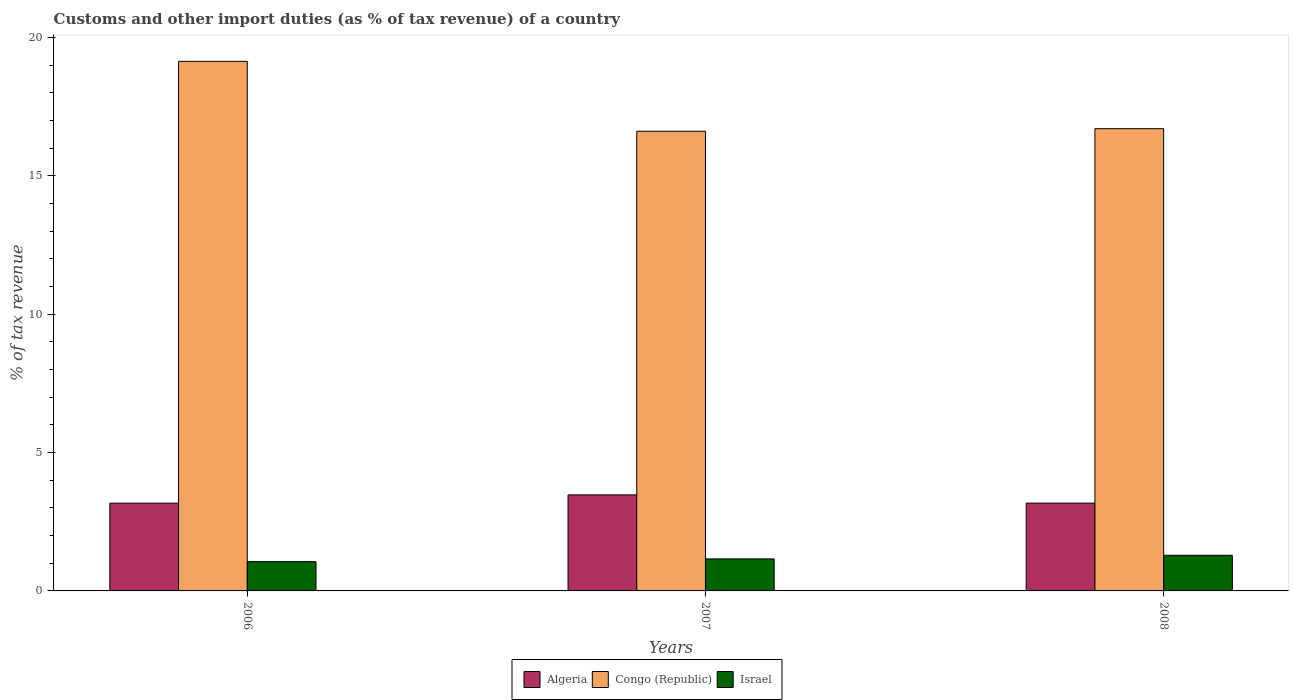How many groups of bars are there?
Your response must be concise. 3. Are the number of bars per tick equal to the number of legend labels?
Provide a short and direct response. Yes. How many bars are there on the 1st tick from the left?
Ensure brevity in your answer.  3. How many bars are there on the 1st tick from the right?
Give a very brief answer. 3. What is the label of the 3rd group of bars from the left?
Your answer should be compact. 2008. What is the percentage of tax revenue from customs in Algeria in 2006?
Your answer should be compact. 3.17. Across all years, what is the maximum percentage of tax revenue from customs in Algeria?
Ensure brevity in your answer.  3.47. Across all years, what is the minimum percentage of tax revenue from customs in Algeria?
Make the answer very short. 3.17. In which year was the percentage of tax revenue from customs in Israel maximum?
Keep it short and to the point. 2008. What is the total percentage of tax revenue from customs in Congo (Republic) in the graph?
Provide a succinct answer. 52.45. What is the difference between the percentage of tax revenue from customs in Congo (Republic) in 2006 and that in 2008?
Keep it short and to the point. 2.43. What is the difference between the percentage of tax revenue from customs in Congo (Republic) in 2008 and the percentage of tax revenue from customs in Israel in 2006?
Offer a very short reply. 15.65. What is the average percentage of tax revenue from customs in Congo (Republic) per year?
Offer a very short reply. 17.48. In the year 2006, what is the difference between the percentage of tax revenue from customs in Congo (Republic) and percentage of tax revenue from customs in Algeria?
Your answer should be very brief. 15.97. In how many years, is the percentage of tax revenue from customs in Israel greater than 15 %?
Your answer should be compact. 0. What is the ratio of the percentage of tax revenue from customs in Congo (Republic) in 2006 to that in 2008?
Your response must be concise. 1.15. Is the percentage of tax revenue from customs in Congo (Republic) in 2007 less than that in 2008?
Your answer should be very brief. Yes. What is the difference between the highest and the second highest percentage of tax revenue from customs in Israel?
Provide a succinct answer. 0.13. What is the difference between the highest and the lowest percentage of tax revenue from customs in Israel?
Keep it short and to the point. 0.23. Is the sum of the percentage of tax revenue from customs in Israel in 2007 and 2008 greater than the maximum percentage of tax revenue from customs in Algeria across all years?
Keep it short and to the point. No. What does the 2nd bar from the left in 2006 represents?
Your answer should be compact. Congo (Republic). What does the 1st bar from the right in 2007 represents?
Your answer should be very brief. Israel. Is it the case that in every year, the sum of the percentage of tax revenue from customs in Congo (Republic) and percentage of tax revenue from customs in Israel is greater than the percentage of tax revenue from customs in Algeria?
Keep it short and to the point. Yes. How many bars are there?
Give a very brief answer. 9. Are all the bars in the graph horizontal?
Offer a very short reply. No. What is the difference between two consecutive major ticks on the Y-axis?
Ensure brevity in your answer.  5. Are the values on the major ticks of Y-axis written in scientific E-notation?
Keep it short and to the point. No. Does the graph contain any zero values?
Give a very brief answer. No. Does the graph contain grids?
Your answer should be compact. No. How many legend labels are there?
Give a very brief answer. 3. How are the legend labels stacked?
Make the answer very short. Horizontal. What is the title of the graph?
Make the answer very short. Customs and other import duties (as % of tax revenue) of a country. Does "Vietnam" appear as one of the legend labels in the graph?
Make the answer very short. No. What is the label or title of the X-axis?
Keep it short and to the point. Years. What is the label or title of the Y-axis?
Provide a short and direct response. % of tax revenue. What is the % of tax revenue in Algeria in 2006?
Your response must be concise. 3.17. What is the % of tax revenue in Congo (Republic) in 2006?
Your answer should be very brief. 19.14. What is the % of tax revenue in Israel in 2006?
Your answer should be very brief. 1.06. What is the % of tax revenue in Algeria in 2007?
Make the answer very short. 3.47. What is the % of tax revenue in Congo (Republic) in 2007?
Provide a succinct answer. 16.61. What is the % of tax revenue in Israel in 2007?
Your answer should be compact. 1.16. What is the % of tax revenue of Algeria in 2008?
Provide a short and direct response. 3.17. What is the % of tax revenue of Congo (Republic) in 2008?
Provide a succinct answer. 16.7. What is the % of tax revenue in Israel in 2008?
Make the answer very short. 1.29. Across all years, what is the maximum % of tax revenue of Algeria?
Your answer should be compact. 3.47. Across all years, what is the maximum % of tax revenue in Congo (Republic)?
Give a very brief answer. 19.14. Across all years, what is the maximum % of tax revenue of Israel?
Offer a very short reply. 1.29. Across all years, what is the minimum % of tax revenue in Algeria?
Give a very brief answer. 3.17. Across all years, what is the minimum % of tax revenue in Congo (Republic)?
Offer a very short reply. 16.61. Across all years, what is the minimum % of tax revenue of Israel?
Provide a succinct answer. 1.06. What is the total % of tax revenue of Algeria in the graph?
Provide a short and direct response. 9.81. What is the total % of tax revenue in Congo (Republic) in the graph?
Give a very brief answer. 52.45. What is the total % of tax revenue of Israel in the graph?
Make the answer very short. 3.5. What is the difference between the % of tax revenue of Algeria in 2006 and that in 2007?
Make the answer very short. -0.3. What is the difference between the % of tax revenue in Congo (Republic) in 2006 and that in 2007?
Your answer should be compact. 2.53. What is the difference between the % of tax revenue in Israel in 2006 and that in 2007?
Make the answer very short. -0.1. What is the difference between the % of tax revenue in Algeria in 2006 and that in 2008?
Your response must be concise. -0. What is the difference between the % of tax revenue of Congo (Republic) in 2006 and that in 2008?
Provide a short and direct response. 2.43. What is the difference between the % of tax revenue of Israel in 2006 and that in 2008?
Your response must be concise. -0.23. What is the difference between the % of tax revenue in Algeria in 2007 and that in 2008?
Your answer should be compact. 0.3. What is the difference between the % of tax revenue of Congo (Republic) in 2007 and that in 2008?
Your answer should be very brief. -0.09. What is the difference between the % of tax revenue in Israel in 2007 and that in 2008?
Your answer should be very brief. -0.13. What is the difference between the % of tax revenue in Algeria in 2006 and the % of tax revenue in Congo (Republic) in 2007?
Keep it short and to the point. -13.44. What is the difference between the % of tax revenue in Algeria in 2006 and the % of tax revenue in Israel in 2007?
Make the answer very short. 2.01. What is the difference between the % of tax revenue in Congo (Republic) in 2006 and the % of tax revenue in Israel in 2007?
Provide a short and direct response. 17.98. What is the difference between the % of tax revenue of Algeria in 2006 and the % of tax revenue of Congo (Republic) in 2008?
Make the answer very short. -13.53. What is the difference between the % of tax revenue in Algeria in 2006 and the % of tax revenue in Israel in 2008?
Your answer should be very brief. 1.88. What is the difference between the % of tax revenue in Congo (Republic) in 2006 and the % of tax revenue in Israel in 2008?
Your answer should be very brief. 17.85. What is the difference between the % of tax revenue in Algeria in 2007 and the % of tax revenue in Congo (Republic) in 2008?
Your answer should be compact. -13.23. What is the difference between the % of tax revenue in Algeria in 2007 and the % of tax revenue in Israel in 2008?
Offer a very short reply. 2.18. What is the difference between the % of tax revenue of Congo (Republic) in 2007 and the % of tax revenue of Israel in 2008?
Offer a terse response. 15.32. What is the average % of tax revenue in Algeria per year?
Provide a short and direct response. 3.27. What is the average % of tax revenue in Congo (Republic) per year?
Keep it short and to the point. 17.48. What is the average % of tax revenue in Israel per year?
Provide a succinct answer. 1.17. In the year 2006, what is the difference between the % of tax revenue in Algeria and % of tax revenue in Congo (Republic)?
Keep it short and to the point. -15.97. In the year 2006, what is the difference between the % of tax revenue of Algeria and % of tax revenue of Israel?
Make the answer very short. 2.11. In the year 2006, what is the difference between the % of tax revenue in Congo (Republic) and % of tax revenue in Israel?
Give a very brief answer. 18.08. In the year 2007, what is the difference between the % of tax revenue of Algeria and % of tax revenue of Congo (Republic)?
Ensure brevity in your answer.  -13.14. In the year 2007, what is the difference between the % of tax revenue in Algeria and % of tax revenue in Israel?
Provide a succinct answer. 2.31. In the year 2007, what is the difference between the % of tax revenue in Congo (Republic) and % of tax revenue in Israel?
Provide a succinct answer. 15.45. In the year 2008, what is the difference between the % of tax revenue in Algeria and % of tax revenue in Congo (Republic)?
Give a very brief answer. -13.53. In the year 2008, what is the difference between the % of tax revenue in Algeria and % of tax revenue in Israel?
Keep it short and to the point. 1.88. In the year 2008, what is the difference between the % of tax revenue in Congo (Republic) and % of tax revenue in Israel?
Your answer should be compact. 15.42. What is the ratio of the % of tax revenue of Algeria in 2006 to that in 2007?
Provide a short and direct response. 0.91. What is the ratio of the % of tax revenue in Congo (Republic) in 2006 to that in 2007?
Give a very brief answer. 1.15. What is the ratio of the % of tax revenue of Israel in 2006 to that in 2007?
Give a very brief answer. 0.91. What is the ratio of the % of tax revenue in Algeria in 2006 to that in 2008?
Make the answer very short. 1. What is the ratio of the % of tax revenue in Congo (Republic) in 2006 to that in 2008?
Offer a very short reply. 1.15. What is the ratio of the % of tax revenue in Israel in 2006 to that in 2008?
Ensure brevity in your answer.  0.82. What is the ratio of the % of tax revenue in Algeria in 2007 to that in 2008?
Give a very brief answer. 1.09. What is the ratio of the % of tax revenue of Israel in 2007 to that in 2008?
Your answer should be compact. 0.9. What is the difference between the highest and the second highest % of tax revenue of Algeria?
Your answer should be very brief. 0.3. What is the difference between the highest and the second highest % of tax revenue of Congo (Republic)?
Make the answer very short. 2.43. What is the difference between the highest and the second highest % of tax revenue in Israel?
Make the answer very short. 0.13. What is the difference between the highest and the lowest % of tax revenue in Algeria?
Offer a terse response. 0.3. What is the difference between the highest and the lowest % of tax revenue of Congo (Republic)?
Ensure brevity in your answer.  2.53. What is the difference between the highest and the lowest % of tax revenue of Israel?
Offer a terse response. 0.23. 